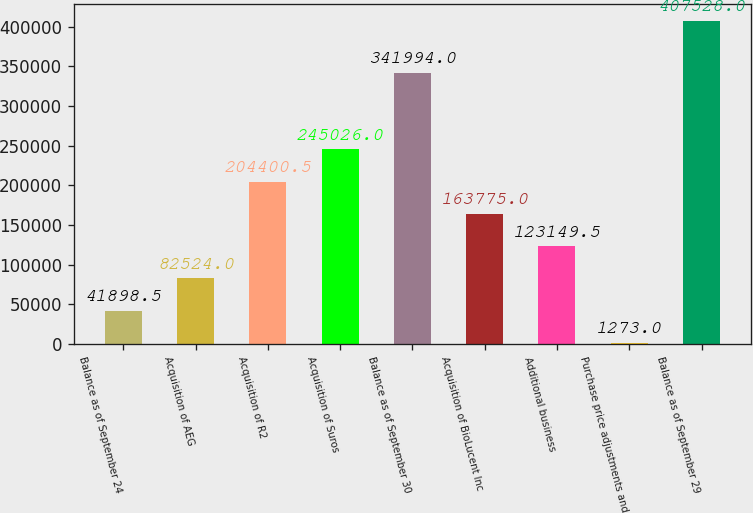<chart> <loc_0><loc_0><loc_500><loc_500><bar_chart><fcel>Balance as of September 24<fcel>Acquisition of AEG<fcel>Acquisition of R2<fcel>Acquisition of Suros<fcel>Balance as of September 30<fcel>Acquisition of BioLucent Inc<fcel>Additional business<fcel>Purchase price adjustments and<fcel>Balance as of September 29<nl><fcel>41898.5<fcel>82524<fcel>204400<fcel>245026<fcel>341994<fcel>163775<fcel>123150<fcel>1273<fcel>407528<nl></chart> 